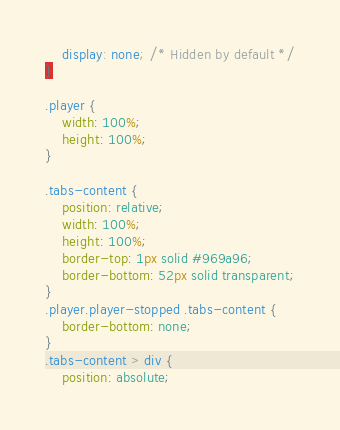Convert code to text. <code><loc_0><loc_0><loc_500><loc_500><_CSS_>	display: none; /* Hidden by default */
}

.player {
	width: 100%;
	height: 100%;
}

.tabs-content {
	position: relative;
	width: 100%;
	height: 100%;
	border-top: 1px solid #969a96;
	border-bottom: 52px solid transparent;
}
.player.player-stopped .tabs-content {
	border-bottom: none;
}
.tabs-content > div {
	position: absolute;</code> 